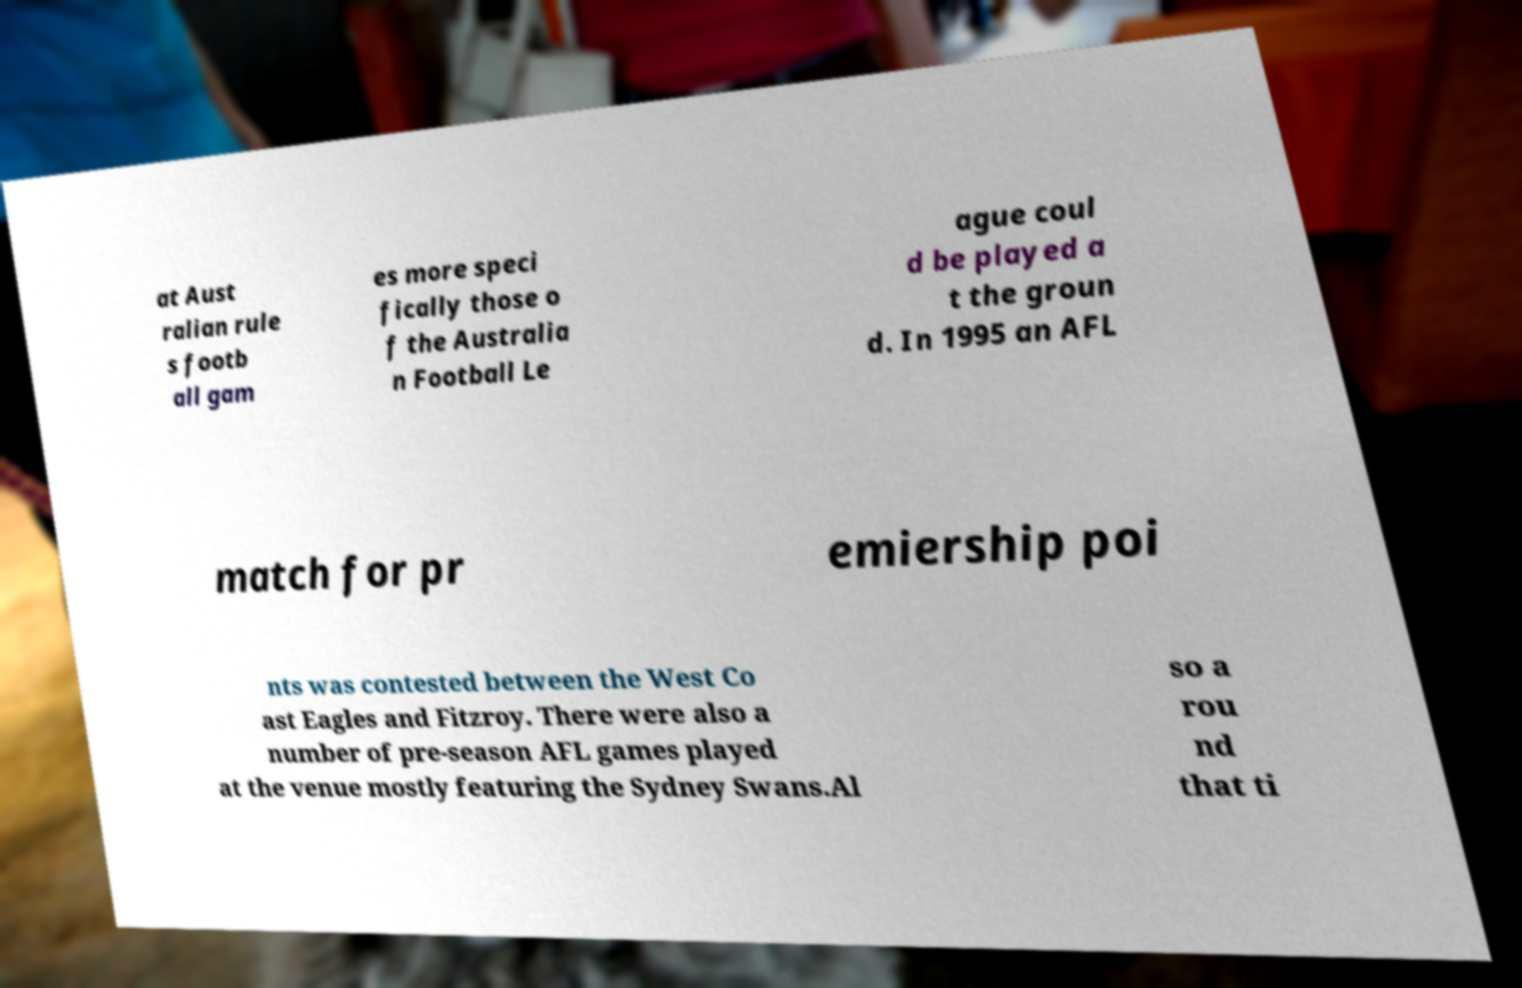Could you extract and type out the text from this image? at Aust ralian rule s footb all gam es more speci fically those o f the Australia n Football Le ague coul d be played a t the groun d. In 1995 an AFL match for pr emiership poi nts was contested between the West Co ast Eagles and Fitzroy. There were also a number of pre-season AFL games played at the venue mostly featuring the Sydney Swans.Al so a rou nd that ti 